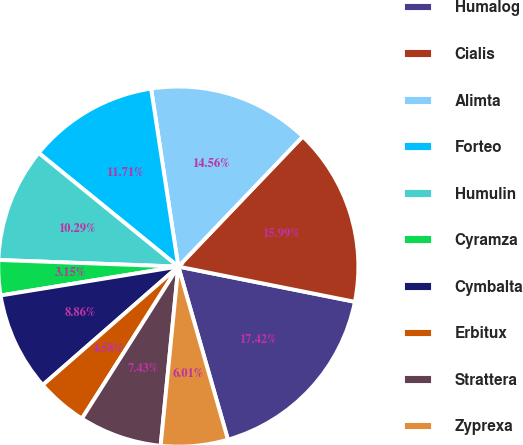<chart> <loc_0><loc_0><loc_500><loc_500><pie_chart><fcel>Humalog<fcel>Cialis<fcel>Alimta<fcel>Forteo<fcel>Humulin<fcel>Cyramza<fcel>Cymbalta<fcel>Erbitux<fcel>Strattera<fcel>Zyprexa<nl><fcel>17.42%<fcel>15.99%<fcel>14.56%<fcel>11.71%<fcel>10.29%<fcel>3.15%<fcel>8.86%<fcel>4.58%<fcel>7.43%<fcel>6.01%<nl></chart> 